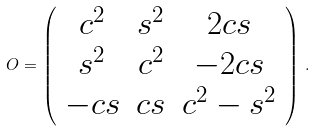<formula> <loc_0><loc_0><loc_500><loc_500>O = \left ( \begin{array} { c c c } c ^ { 2 } & s ^ { 2 } & 2 c s \\ s ^ { 2 } & c ^ { 2 } & - 2 c s \\ - c s & c s & c ^ { 2 } - s ^ { 2 } \end{array} \right ) \, .</formula> 